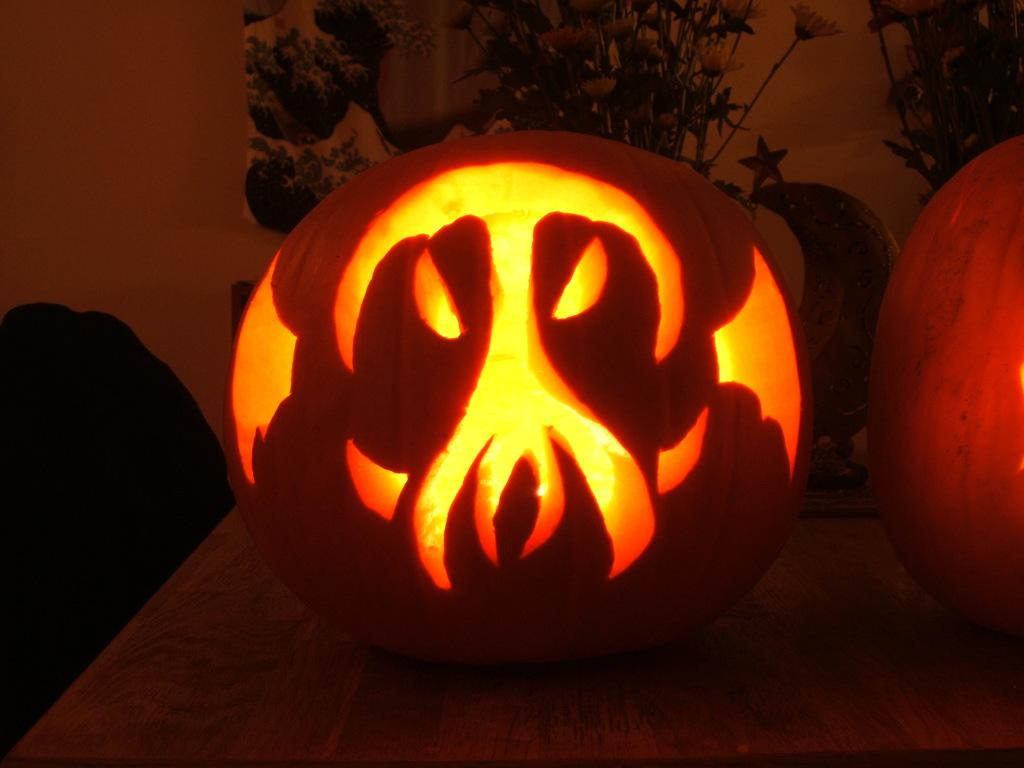How many pumpkins are on the table in the image? There are two pumpkins on the table in the image. What can be seen in the background of the image? There is a group of flowers and a star visible in the background. What type of object is present in the background? There is a sculpture in the background. What type of toothpaste is being used to decorate the pumpkins in the image? There is no toothpaste present in the image, and the pumpkins are not being decorated. 